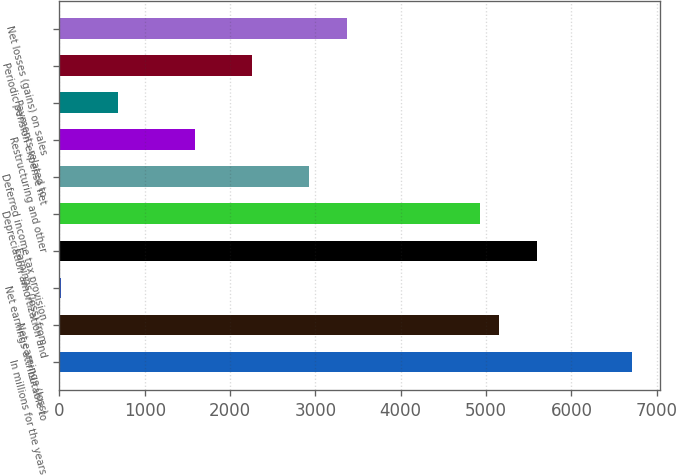Convert chart to OTSL. <chart><loc_0><loc_0><loc_500><loc_500><bar_chart><fcel>In millions for the years<fcel>Net earnings (loss)<fcel>Net earnings attributable to<fcel>Earnings (loss) from<fcel>Depreciation amortization and<fcel>Deferred income tax provision<fcel>Restructuring and other<fcel>Payments related to<fcel>Periodic pension expense net<fcel>Net losses (gains) on sales<nl><fcel>6708<fcel>5148.4<fcel>24<fcel>5594<fcel>4925.6<fcel>2920.4<fcel>1583.6<fcel>692.4<fcel>2252<fcel>3366<nl></chart> 